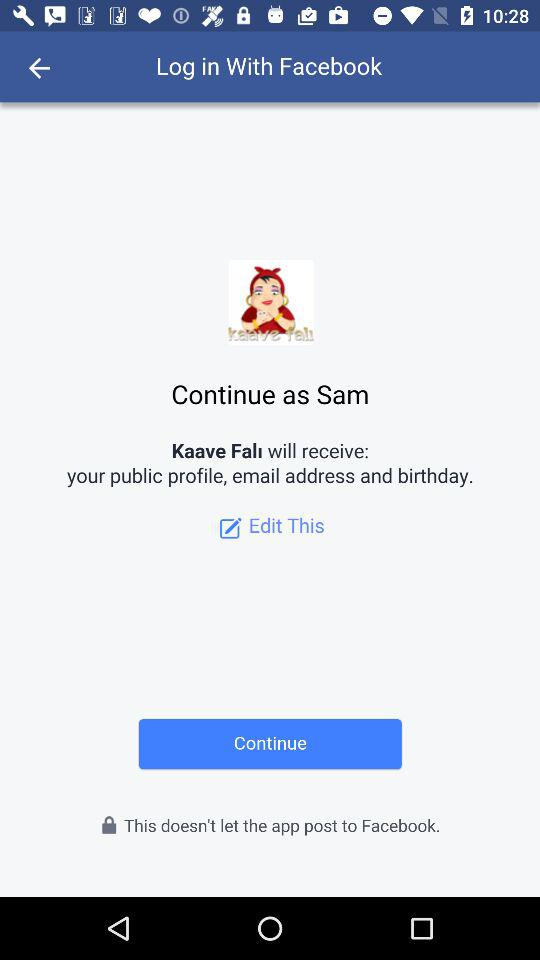What is the application name? The applications names are "Facebook" and "Kaave Falı". 